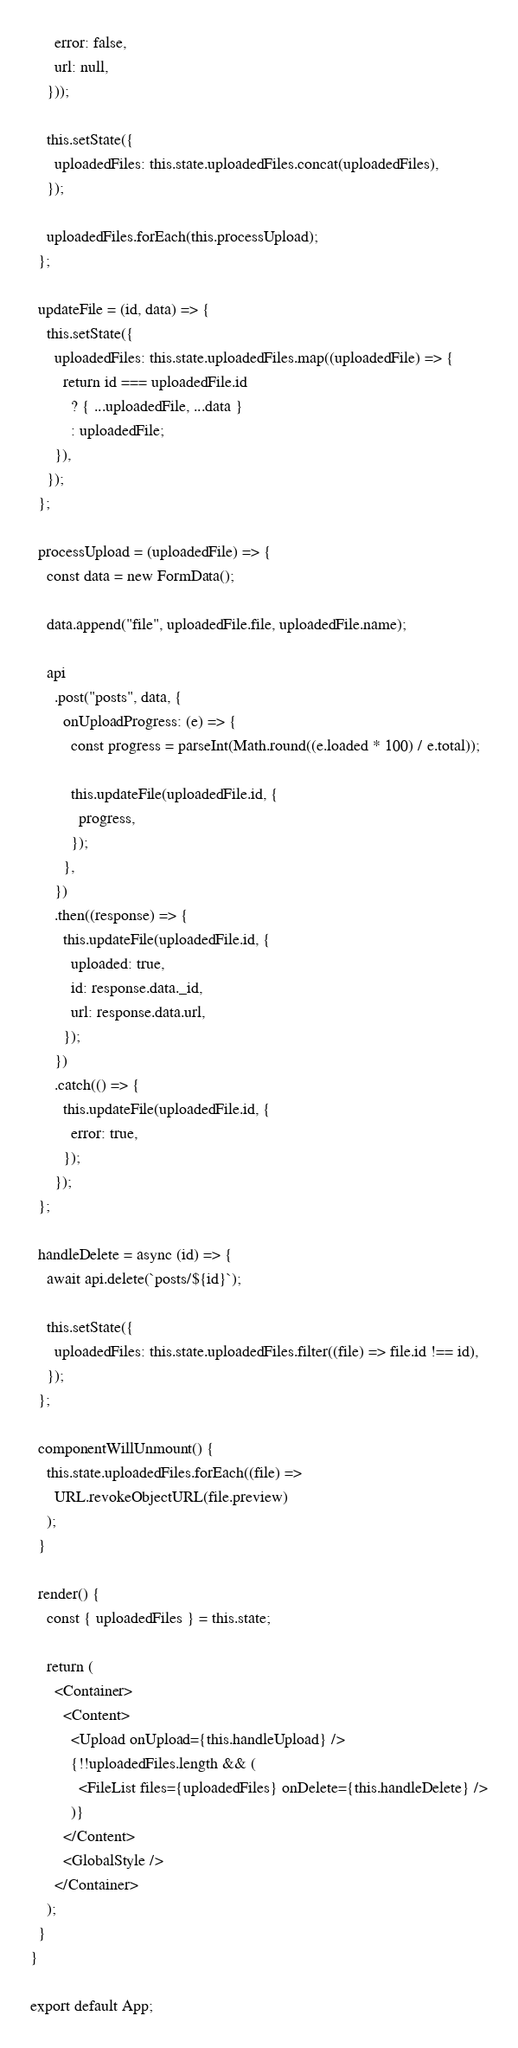Convert code to text. <code><loc_0><loc_0><loc_500><loc_500><_JavaScript_>      error: false,
      url: null,
    }));

    this.setState({
      uploadedFiles: this.state.uploadedFiles.concat(uploadedFiles),
    });

    uploadedFiles.forEach(this.processUpload);
  };

  updateFile = (id, data) => {
    this.setState({
      uploadedFiles: this.state.uploadedFiles.map((uploadedFile) => {
        return id === uploadedFile.id
          ? { ...uploadedFile, ...data }
          : uploadedFile;
      }),
    });
  };

  processUpload = (uploadedFile) => {
    const data = new FormData();

    data.append("file", uploadedFile.file, uploadedFile.name);

    api
      .post("posts", data, {
        onUploadProgress: (e) => {
          const progress = parseInt(Math.round((e.loaded * 100) / e.total));

          this.updateFile(uploadedFile.id, {
            progress,
          });
        },
      })
      .then((response) => {
        this.updateFile(uploadedFile.id, {
          uploaded: true,
          id: response.data._id,
          url: response.data.url,
        });
      })
      .catch(() => {
        this.updateFile(uploadedFile.id, {
          error: true,
        });
      });
  };

  handleDelete = async (id) => {
    await api.delete(`posts/${id}`);

    this.setState({
      uploadedFiles: this.state.uploadedFiles.filter((file) => file.id !== id),
    });
  };

  componentWillUnmount() {
    this.state.uploadedFiles.forEach((file) =>
      URL.revokeObjectURL(file.preview)
    );
  }

  render() {
    const { uploadedFiles } = this.state;

    return (
      <Container>
        <Content>
          <Upload onUpload={this.handleUpload} />
          {!!uploadedFiles.length && (
            <FileList files={uploadedFiles} onDelete={this.handleDelete} />
          )}
        </Content>
        <GlobalStyle />
      </Container>
    );
  }
}

export default App;
</code> 